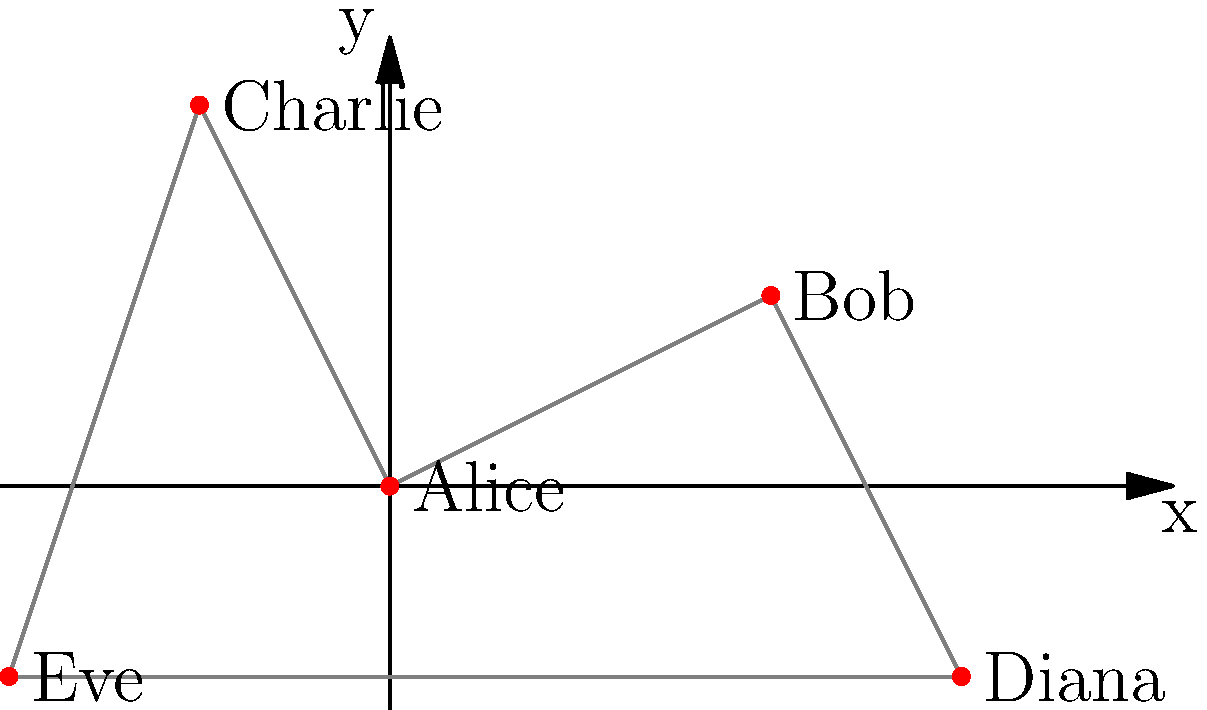In this social network graph of character relationships, Alice forms the central node. If we were to calculate the average distance of all characters from Alice, which character would need to be excluded to maximize this average? Explain your reasoning in terms of narrative dynamics and character interactions. To solve this problem, we need to follow these steps:

1. Identify the distances of each character from Alice:
   - Bob: $\sqrt{2^2 + 1^2} = \sqrt{5}$
   - Charlie: $\sqrt{(-1)^2 + 2^2} = \sqrt{5}$
   - Diana: $\sqrt{3^2 + (-1)^2} = \sqrt{10}$
   - Eve: $\sqrt{(-2)^2 + (-1)^2} = \sqrt{5}$

2. Calculate the current average distance:
   $\frac{\sqrt{5} + \sqrt{5} + \sqrt{10} + \sqrt{5}}{4} = \frac{3\sqrt{5} + \sqrt{10}}{4}$

3. To maximize the average, we need to remove the character closest to Alice. In this case, Bob, Charlie, and Eve are all equally close.

4. Removing any of these three would result in the same maximum average:
   $\frac{\sqrt{5} + \sqrt{5} + \sqrt{10}}{3} = \frac{2\sqrt{5} + \sqrt{10}}{3}$

5. From a narrative perspective, we should consider which character's removal would create the most interesting story dynamics. Eve, being indirectly connected to Alice through Charlie, offers the most potential for narrative tension and complexity.

By removing Eve, we not only maximize the average distance mathematically but also create a narrative where Alice's network becomes more linear, potentially increasing the dramatic potential for miscommunication or conflict between the remaining characters.
Answer: Eve 